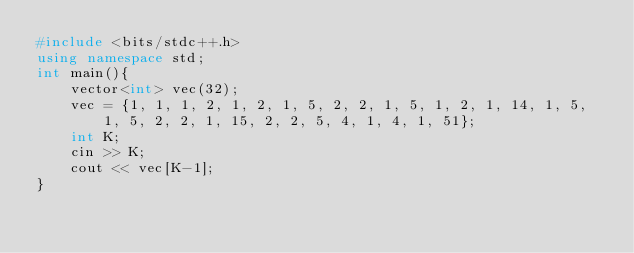Convert code to text. <code><loc_0><loc_0><loc_500><loc_500><_C++_>#include <bits/stdc++.h>
using namespace std;
int main(){
    vector<int> vec(32); 
    vec = {1, 1, 1, 2, 1, 2, 1, 5, 2, 2, 1, 5, 1, 2, 1, 14, 1, 5, 1, 5, 2, 2, 1, 15, 2, 2, 5, 4, 1, 4, 1, 51};
    int K;
    cin >> K;
    cout << vec[K-1];
}</code> 